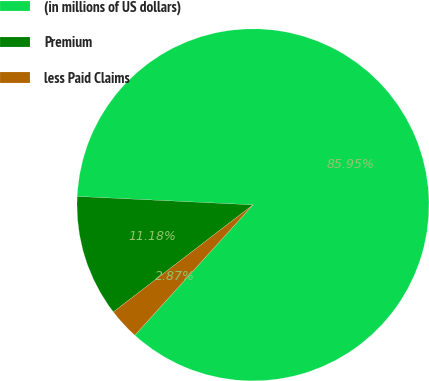Convert chart. <chart><loc_0><loc_0><loc_500><loc_500><pie_chart><fcel>(in millions of US dollars)<fcel>Premium<fcel>less Paid Claims<nl><fcel>85.96%<fcel>11.18%<fcel>2.87%<nl></chart> 